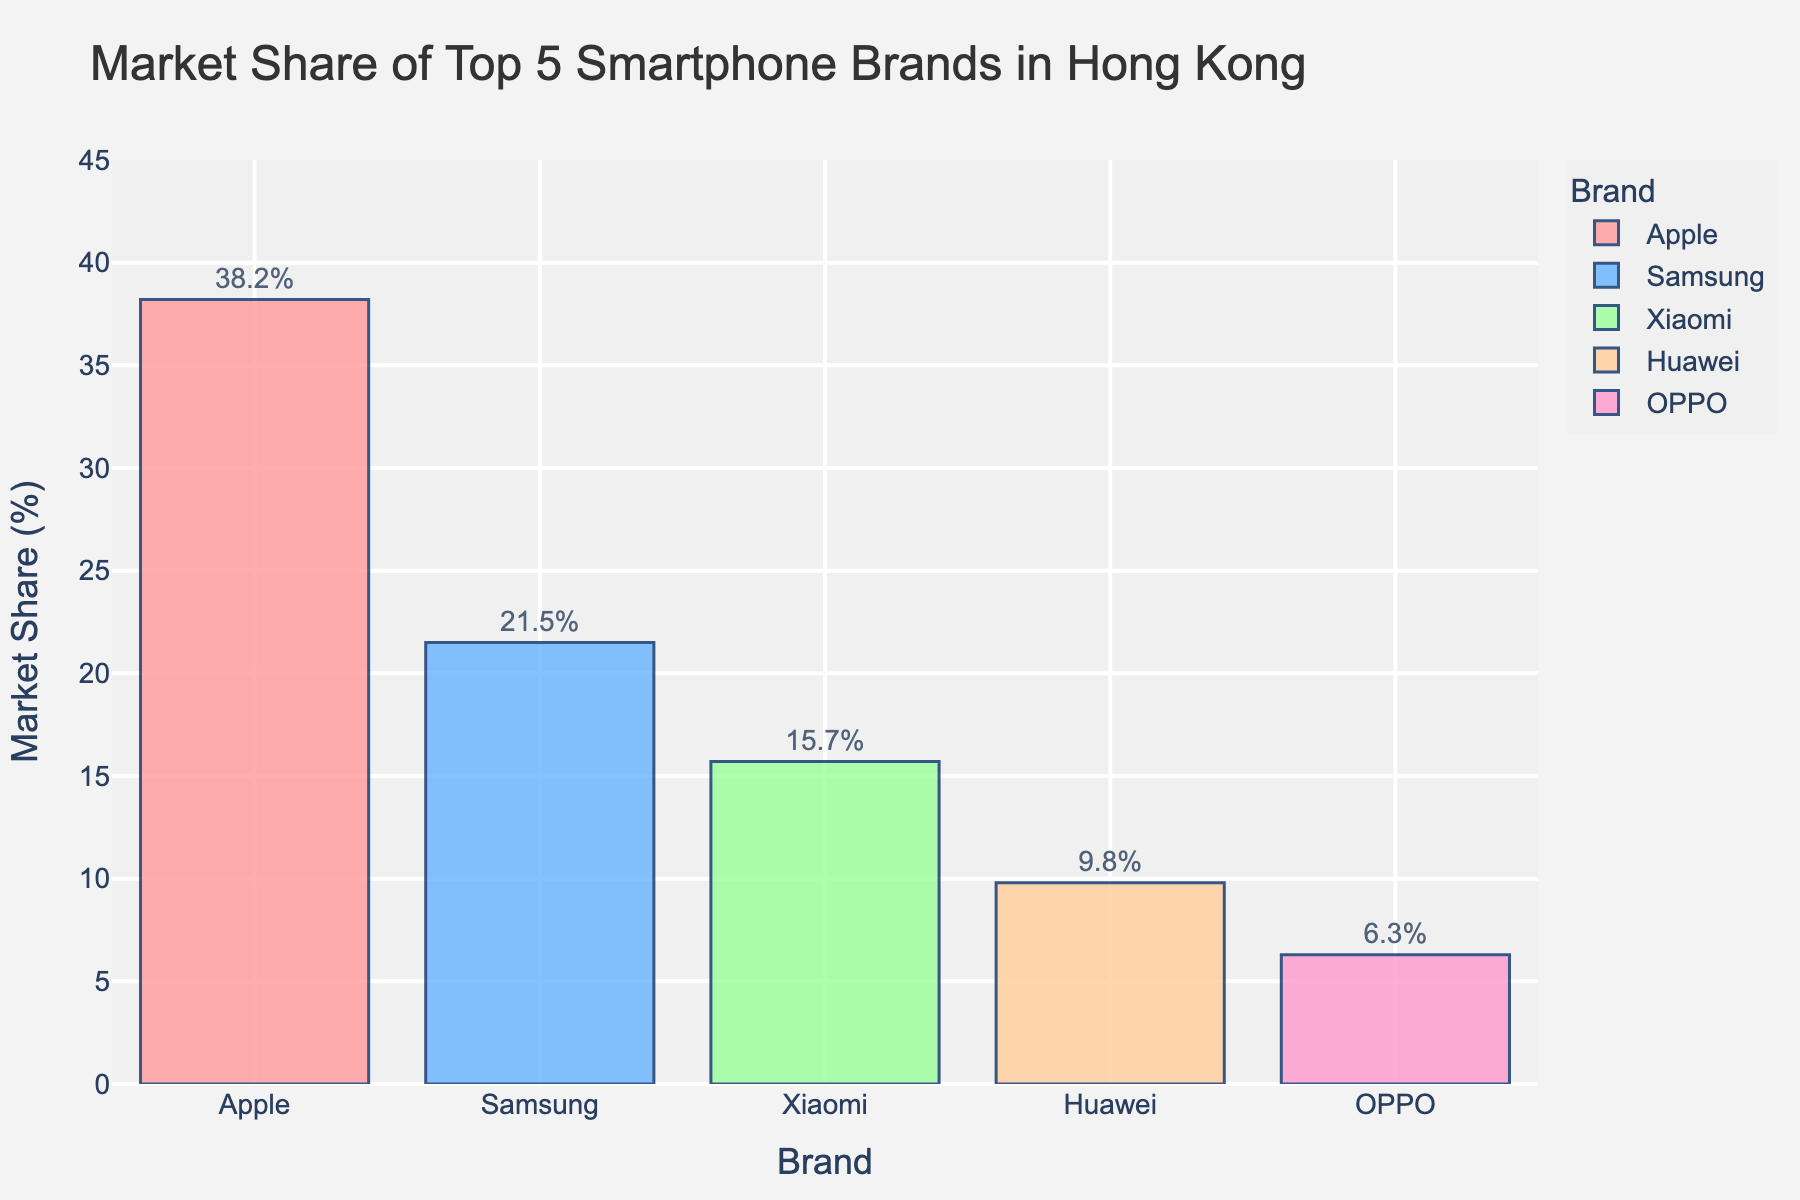What is the market share percentage of Apple? Apple has a market share of 38.2%, which is indicated by the height of the bar labeled 'Apple' reaching 38.2% on the y-axis.
Answer: 38.2% Which brand has the second largest market share? The second tallest bar corresponds to Samsung, indicating it has the second largest market share of 21.5%.
Answer: Samsung What is the difference in market share between Xiaomi and OPPO? Xiaomi's market share is 15.7%, and OPPO's market share is 6.3%. The difference is calculated as 15.7% - 6.3%.
Answer: 9.4% Rank the brands from highest to lowest market share. The bars in the chart are ordered from tallest to shortest as follows: Apple (38.2%), Samsung (21.5%), Xiaomi (15.7%), Huawei (9.8%), OPPO (6.3%).
Answer: Apple, Samsung, Xiaomi, Huawei, OPPO How much more market share does Apple have compared to Huawei? Apple's market share is 38.2% and Huawei's is 9.8%. The difference is calculated as 38.2% - 9.8%.
Answer: 28.4% What is the total market share of the top three brands? The market shares of the top three brands (Apple, Samsung, Xiaomi) are 38.2%, 21.5%, and 15.7% respectively. Summing these up: 38.2% + 21.5% + 15.7%.
Answer: 75.4% Is there any brand that has a market share less than 10%? By observing the heights of the bars, both Huawei (9.8%) and OPPO (6.3%) have market shares less than 10%.
Answer: Yes Which brand has the lowest market share? The shortest bar corresponds to OPPO with a market share of 6.3%.
Answer: OPPO What is the average market share of all five brands? Summing the market shares of all five brands: 38.2% + 21.5% + 15.7% + 9.8% + 6.3% = 91.5%. Then, divide by the number of brands: 91.5% / 5.
Answer: 18.3% How does Samsung's market share compare to Xiaomi's? Samsung has a market share of 21.5% and Xiaomi has 15.7%. Samsung's market share is larger by comparing their bar heights.
Answer: Samsung has a larger market share 